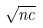Convert formula to latex. <formula><loc_0><loc_0><loc_500><loc_500>\sqrt { n c }</formula> 